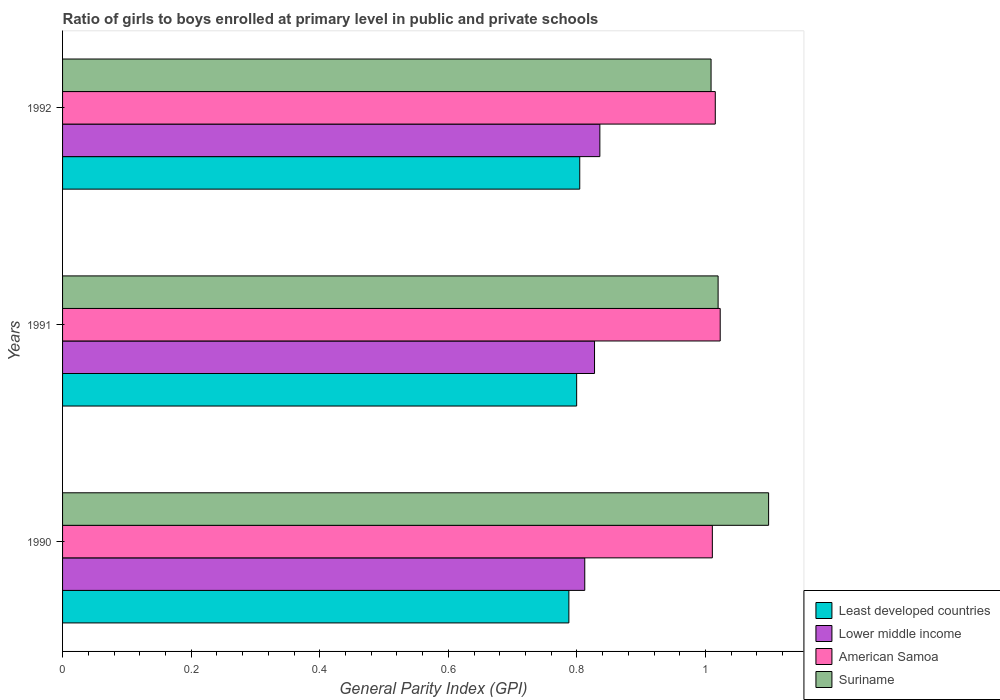Are the number of bars per tick equal to the number of legend labels?
Your answer should be very brief. Yes. How many bars are there on the 1st tick from the top?
Provide a short and direct response. 4. What is the label of the 1st group of bars from the top?
Provide a succinct answer. 1992. What is the general parity index in Lower middle income in 1990?
Make the answer very short. 0.81. Across all years, what is the maximum general parity index in Suriname?
Provide a succinct answer. 1.1. Across all years, what is the minimum general parity index in Least developed countries?
Make the answer very short. 0.79. What is the total general parity index in Suriname in the graph?
Provide a succinct answer. 3.13. What is the difference between the general parity index in Suriname in 1991 and that in 1992?
Your answer should be compact. 0.01. What is the difference between the general parity index in Lower middle income in 1990 and the general parity index in American Samoa in 1991?
Offer a very short reply. -0.21. What is the average general parity index in Lower middle income per year?
Make the answer very short. 0.83. In the year 1990, what is the difference between the general parity index in Suriname and general parity index in Lower middle income?
Keep it short and to the point. 0.29. In how many years, is the general parity index in American Samoa greater than 0.52 ?
Give a very brief answer. 3. What is the ratio of the general parity index in Least developed countries in 1990 to that in 1991?
Keep it short and to the point. 0.98. Is the general parity index in American Samoa in 1990 less than that in 1991?
Your answer should be compact. Yes. Is the difference between the general parity index in Suriname in 1990 and 1991 greater than the difference between the general parity index in Lower middle income in 1990 and 1991?
Keep it short and to the point. Yes. What is the difference between the highest and the second highest general parity index in American Samoa?
Give a very brief answer. 0.01. What is the difference between the highest and the lowest general parity index in Lower middle income?
Your answer should be very brief. 0.02. Is the sum of the general parity index in Lower middle income in 1990 and 1992 greater than the maximum general parity index in Least developed countries across all years?
Your answer should be compact. Yes. What does the 1st bar from the top in 1991 represents?
Your response must be concise. Suriname. What does the 3rd bar from the bottom in 1991 represents?
Your response must be concise. American Samoa. How many years are there in the graph?
Your answer should be compact. 3. Where does the legend appear in the graph?
Make the answer very short. Bottom right. How are the legend labels stacked?
Your response must be concise. Vertical. What is the title of the graph?
Your answer should be compact. Ratio of girls to boys enrolled at primary level in public and private schools. What is the label or title of the X-axis?
Offer a very short reply. General Parity Index (GPI). What is the General Parity Index (GPI) in Least developed countries in 1990?
Offer a very short reply. 0.79. What is the General Parity Index (GPI) in Lower middle income in 1990?
Keep it short and to the point. 0.81. What is the General Parity Index (GPI) in American Samoa in 1990?
Offer a very short reply. 1.01. What is the General Parity Index (GPI) in Suriname in 1990?
Your answer should be compact. 1.1. What is the General Parity Index (GPI) of Least developed countries in 1991?
Your response must be concise. 0.8. What is the General Parity Index (GPI) of Lower middle income in 1991?
Your response must be concise. 0.83. What is the General Parity Index (GPI) in American Samoa in 1991?
Your response must be concise. 1.02. What is the General Parity Index (GPI) in Suriname in 1991?
Make the answer very short. 1.02. What is the General Parity Index (GPI) in Least developed countries in 1992?
Offer a very short reply. 0.8. What is the General Parity Index (GPI) in Lower middle income in 1992?
Make the answer very short. 0.84. What is the General Parity Index (GPI) of American Samoa in 1992?
Offer a terse response. 1.02. What is the General Parity Index (GPI) in Suriname in 1992?
Give a very brief answer. 1.01. Across all years, what is the maximum General Parity Index (GPI) of Least developed countries?
Provide a short and direct response. 0.8. Across all years, what is the maximum General Parity Index (GPI) of Lower middle income?
Offer a terse response. 0.84. Across all years, what is the maximum General Parity Index (GPI) of American Samoa?
Offer a very short reply. 1.02. Across all years, what is the maximum General Parity Index (GPI) of Suriname?
Give a very brief answer. 1.1. Across all years, what is the minimum General Parity Index (GPI) of Least developed countries?
Make the answer very short. 0.79. Across all years, what is the minimum General Parity Index (GPI) in Lower middle income?
Offer a terse response. 0.81. Across all years, what is the minimum General Parity Index (GPI) of American Samoa?
Keep it short and to the point. 1.01. Across all years, what is the minimum General Parity Index (GPI) in Suriname?
Provide a succinct answer. 1.01. What is the total General Parity Index (GPI) in Least developed countries in the graph?
Your answer should be very brief. 2.39. What is the total General Parity Index (GPI) of Lower middle income in the graph?
Ensure brevity in your answer.  2.48. What is the total General Parity Index (GPI) of American Samoa in the graph?
Ensure brevity in your answer.  3.05. What is the total General Parity Index (GPI) in Suriname in the graph?
Provide a succinct answer. 3.13. What is the difference between the General Parity Index (GPI) in Least developed countries in 1990 and that in 1991?
Provide a short and direct response. -0.01. What is the difference between the General Parity Index (GPI) of Lower middle income in 1990 and that in 1991?
Your response must be concise. -0.02. What is the difference between the General Parity Index (GPI) in American Samoa in 1990 and that in 1991?
Your answer should be very brief. -0.01. What is the difference between the General Parity Index (GPI) of Suriname in 1990 and that in 1991?
Provide a succinct answer. 0.08. What is the difference between the General Parity Index (GPI) in Least developed countries in 1990 and that in 1992?
Your response must be concise. -0.02. What is the difference between the General Parity Index (GPI) of Lower middle income in 1990 and that in 1992?
Provide a succinct answer. -0.02. What is the difference between the General Parity Index (GPI) of American Samoa in 1990 and that in 1992?
Your answer should be very brief. -0. What is the difference between the General Parity Index (GPI) in Suriname in 1990 and that in 1992?
Provide a short and direct response. 0.09. What is the difference between the General Parity Index (GPI) of Least developed countries in 1991 and that in 1992?
Provide a short and direct response. -0. What is the difference between the General Parity Index (GPI) of Lower middle income in 1991 and that in 1992?
Your response must be concise. -0.01. What is the difference between the General Parity Index (GPI) in American Samoa in 1991 and that in 1992?
Give a very brief answer. 0.01. What is the difference between the General Parity Index (GPI) in Suriname in 1991 and that in 1992?
Make the answer very short. 0.01. What is the difference between the General Parity Index (GPI) of Least developed countries in 1990 and the General Parity Index (GPI) of Lower middle income in 1991?
Keep it short and to the point. -0.04. What is the difference between the General Parity Index (GPI) in Least developed countries in 1990 and the General Parity Index (GPI) in American Samoa in 1991?
Offer a very short reply. -0.24. What is the difference between the General Parity Index (GPI) of Least developed countries in 1990 and the General Parity Index (GPI) of Suriname in 1991?
Your response must be concise. -0.23. What is the difference between the General Parity Index (GPI) in Lower middle income in 1990 and the General Parity Index (GPI) in American Samoa in 1991?
Ensure brevity in your answer.  -0.21. What is the difference between the General Parity Index (GPI) in Lower middle income in 1990 and the General Parity Index (GPI) in Suriname in 1991?
Give a very brief answer. -0.21. What is the difference between the General Parity Index (GPI) in American Samoa in 1990 and the General Parity Index (GPI) in Suriname in 1991?
Your response must be concise. -0.01. What is the difference between the General Parity Index (GPI) in Least developed countries in 1990 and the General Parity Index (GPI) in Lower middle income in 1992?
Offer a very short reply. -0.05. What is the difference between the General Parity Index (GPI) in Least developed countries in 1990 and the General Parity Index (GPI) in American Samoa in 1992?
Give a very brief answer. -0.23. What is the difference between the General Parity Index (GPI) of Least developed countries in 1990 and the General Parity Index (GPI) of Suriname in 1992?
Offer a terse response. -0.22. What is the difference between the General Parity Index (GPI) of Lower middle income in 1990 and the General Parity Index (GPI) of American Samoa in 1992?
Your response must be concise. -0.2. What is the difference between the General Parity Index (GPI) of Lower middle income in 1990 and the General Parity Index (GPI) of Suriname in 1992?
Offer a terse response. -0.2. What is the difference between the General Parity Index (GPI) in American Samoa in 1990 and the General Parity Index (GPI) in Suriname in 1992?
Offer a very short reply. 0. What is the difference between the General Parity Index (GPI) of Least developed countries in 1991 and the General Parity Index (GPI) of Lower middle income in 1992?
Your answer should be very brief. -0.04. What is the difference between the General Parity Index (GPI) in Least developed countries in 1991 and the General Parity Index (GPI) in American Samoa in 1992?
Provide a short and direct response. -0.22. What is the difference between the General Parity Index (GPI) in Least developed countries in 1991 and the General Parity Index (GPI) in Suriname in 1992?
Provide a short and direct response. -0.21. What is the difference between the General Parity Index (GPI) of Lower middle income in 1991 and the General Parity Index (GPI) of American Samoa in 1992?
Ensure brevity in your answer.  -0.19. What is the difference between the General Parity Index (GPI) in Lower middle income in 1991 and the General Parity Index (GPI) in Suriname in 1992?
Make the answer very short. -0.18. What is the difference between the General Parity Index (GPI) of American Samoa in 1991 and the General Parity Index (GPI) of Suriname in 1992?
Provide a short and direct response. 0.01. What is the average General Parity Index (GPI) of Least developed countries per year?
Make the answer very short. 0.8. What is the average General Parity Index (GPI) of Lower middle income per year?
Give a very brief answer. 0.83. What is the average General Parity Index (GPI) in American Samoa per year?
Offer a very short reply. 1.02. What is the average General Parity Index (GPI) of Suriname per year?
Your response must be concise. 1.04. In the year 1990, what is the difference between the General Parity Index (GPI) in Least developed countries and General Parity Index (GPI) in Lower middle income?
Your answer should be compact. -0.02. In the year 1990, what is the difference between the General Parity Index (GPI) in Least developed countries and General Parity Index (GPI) in American Samoa?
Your answer should be very brief. -0.22. In the year 1990, what is the difference between the General Parity Index (GPI) in Least developed countries and General Parity Index (GPI) in Suriname?
Give a very brief answer. -0.31. In the year 1990, what is the difference between the General Parity Index (GPI) in Lower middle income and General Parity Index (GPI) in American Samoa?
Offer a terse response. -0.2. In the year 1990, what is the difference between the General Parity Index (GPI) of Lower middle income and General Parity Index (GPI) of Suriname?
Your answer should be very brief. -0.29. In the year 1990, what is the difference between the General Parity Index (GPI) in American Samoa and General Parity Index (GPI) in Suriname?
Make the answer very short. -0.09. In the year 1991, what is the difference between the General Parity Index (GPI) of Least developed countries and General Parity Index (GPI) of Lower middle income?
Provide a succinct answer. -0.03. In the year 1991, what is the difference between the General Parity Index (GPI) in Least developed countries and General Parity Index (GPI) in American Samoa?
Your response must be concise. -0.22. In the year 1991, what is the difference between the General Parity Index (GPI) of Least developed countries and General Parity Index (GPI) of Suriname?
Give a very brief answer. -0.22. In the year 1991, what is the difference between the General Parity Index (GPI) in Lower middle income and General Parity Index (GPI) in American Samoa?
Your answer should be compact. -0.2. In the year 1991, what is the difference between the General Parity Index (GPI) of Lower middle income and General Parity Index (GPI) of Suriname?
Give a very brief answer. -0.19. In the year 1991, what is the difference between the General Parity Index (GPI) in American Samoa and General Parity Index (GPI) in Suriname?
Your answer should be very brief. 0. In the year 1992, what is the difference between the General Parity Index (GPI) of Least developed countries and General Parity Index (GPI) of Lower middle income?
Keep it short and to the point. -0.03. In the year 1992, what is the difference between the General Parity Index (GPI) in Least developed countries and General Parity Index (GPI) in American Samoa?
Give a very brief answer. -0.21. In the year 1992, what is the difference between the General Parity Index (GPI) of Least developed countries and General Parity Index (GPI) of Suriname?
Give a very brief answer. -0.2. In the year 1992, what is the difference between the General Parity Index (GPI) of Lower middle income and General Parity Index (GPI) of American Samoa?
Keep it short and to the point. -0.18. In the year 1992, what is the difference between the General Parity Index (GPI) of Lower middle income and General Parity Index (GPI) of Suriname?
Your answer should be compact. -0.17. In the year 1992, what is the difference between the General Parity Index (GPI) of American Samoa and General Parity Index (GPI) of Suriname?
Your answer should be very brief. 0.01. What is the ratio of the General Parity Index (GPI) in Least developed countries in 1990 to that in 1991?
Provide a succinct answer. 0.98. What is the ratio of the General Parity Index (GPI) of Lower middle income in 1990 to that in 1991?
Keep it short and to the point. 0.98. What is the ratio of the General Parity Index (GPI) of Suriname in 1990 to that in 1991?
Your answer should be compact. 1.08. What is the ratio of the General Parity Index (GPI) in Least developed countries in 1990 to that in 1992?
Offer a very short reply. 0.98. What is the ratio of the General Parity Index (GPI) of Lower middle income in 1990 to that in 1992?
Provide a short and direct response. 0.97. What is the ratio of the General Parity Index (GPI) of Suriname in 1990 to that in 1992?
Give a very brief answer. 1.09. What is the ratio of the General Parity Index (GPI) of Lower middle income in 1991 to that in 1992?
Your response must be concise. 0.99. What is the ratio of the General Parity Index (GPI) in American Samoa in 1991 to that in 1992?
Your answer should be very brief. 1.01. What is the ratio of the General Parity Index (GPI) in Suriname in 1991 to that in 1992?
Give a very brief answer. 1.01. What is the difference between the highest and the second highest General Parity Index (GPI) in Least developed countries?
Ensure brevity in your answer.  0. What is the difference between the highest and the second highest General Parity Index (GPI) in Lower middle income?
Keep it short and to the point. 0.01. What is the difference between the highest and the second highest General Parity Index (GPI) in American Samoa?
Ensure brevity in your answer.  0.01. What is the difference between the highest and the second highest General Parity Index (GPI) in Suriname?
Make the answer very short. 0.08. What is the difference between the highest and the lowest General Parity Index (GPI) in Least developed countries?
Offer a terse response. 0.02. What is the difference between the highest and the lowest General Parity Index (GPI) in Lower middle income?
Make the answer very short. 0.02. What is the difference between the highest and the lowest General Parity Index (GPI) in American Samoa?
Provide a short and direct response. 0.01. What is the difference between the highest and the lowest General Parity Index (GPI) of Suriname?
Offer a very short reply. 0.09. 